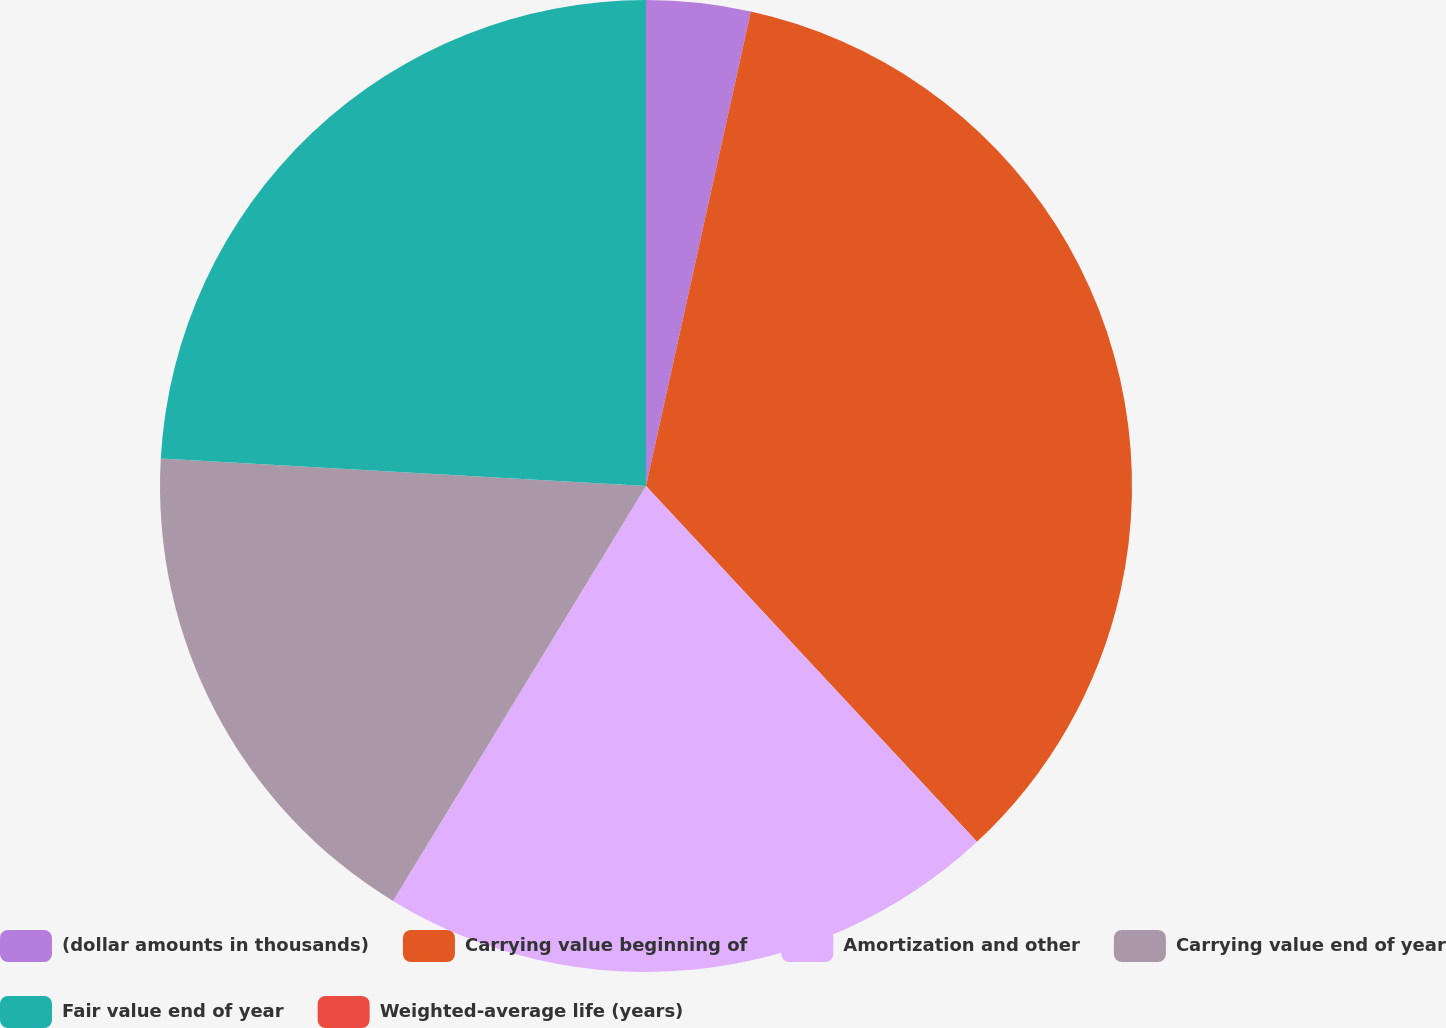Convert chart to OTSL. <chart><loc_0><loc_0><loc_500><loc_500><pie_chart><fcel>(dollar amounts in thousands)<fcel>Carrying value beginning of<fcel>Amortization and other<fcel>Carrying value end of year<fcel>Fair value end of year<fcel>Weighted-average life (years)<nl><fcel>3.46%<fcel>34.61%<fcel>20.64%<fcel>17.18%<fcel>24.1%<fcel>0.0%<nl></chart> 